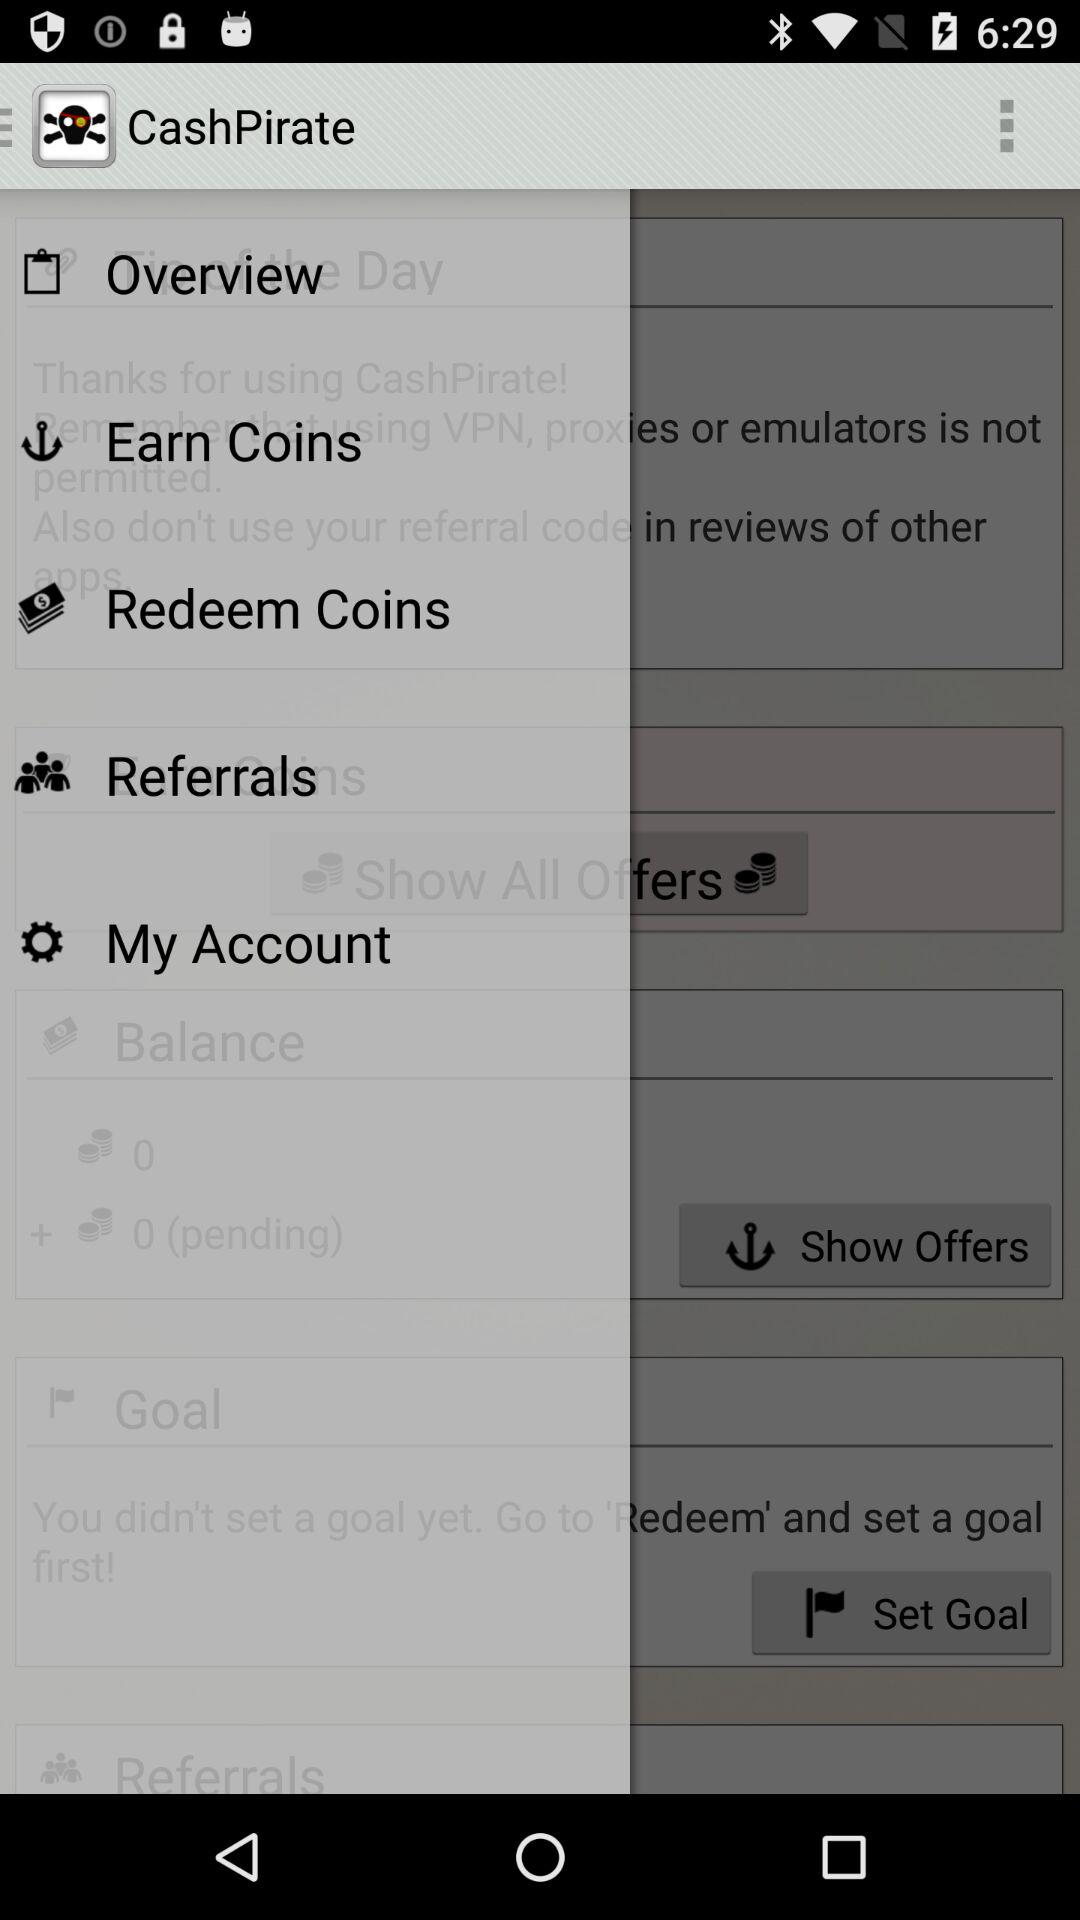What is the name of the application? The name of the application is "CashPirate". 